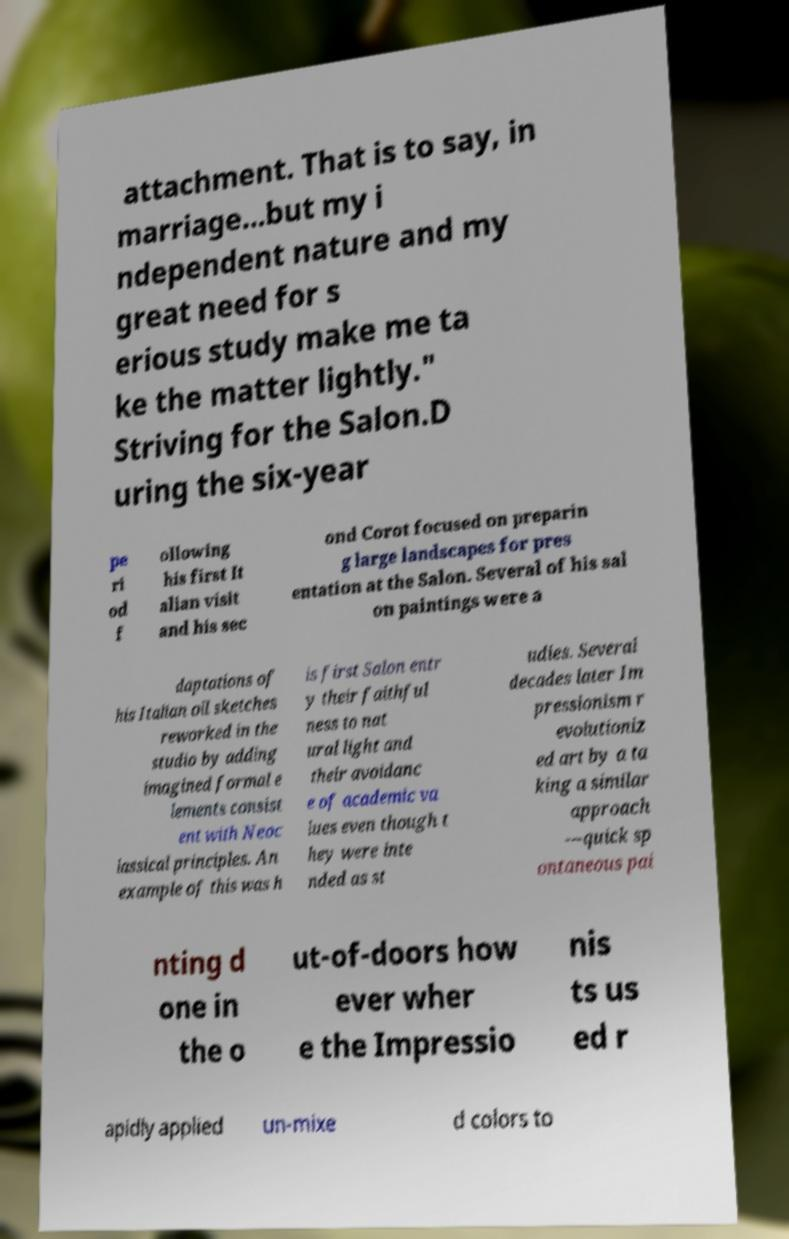Please identify and transcribe the text found in this image. attachment. That is to say, in marriage...but my i ndependent nature and my great need for s erious study make me ta ke the matter lightly." Striving for the Salon.D uring the six-year pe ri od f ollowing his first It alian visit and his sec ond Corot focused on preparin g large landscapes for pres entation at the Salon. Several of his sal on paintings were a daptations of his Italian oil sketches reworked in the studio by adding imagined formal e lements consist ent with Neoc lassical principles. An example of this was h is first Salon entr y their faithful ness to nat ural light and their avoidanc e of academic va lues even though t hey were inte nded as st udies. Several decades later Im pressionism r evolutioniz ed art by a ta king a similar approach —quick sp ontaneous pai nting d one in the o ut-of-doors how ever wher e the Impressio nis ts us ed r apidly applied un-mixe d colors to 